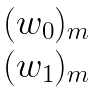Convert formula to latex. <formula><loc_0><loc_0><loc_500><loc_500>\begin{matrix} \, ( w _ { 0 } ) _ { m } \, \\ \, ( w _ { 1 } ) _ { m } \, \end{matrix}</formula> 